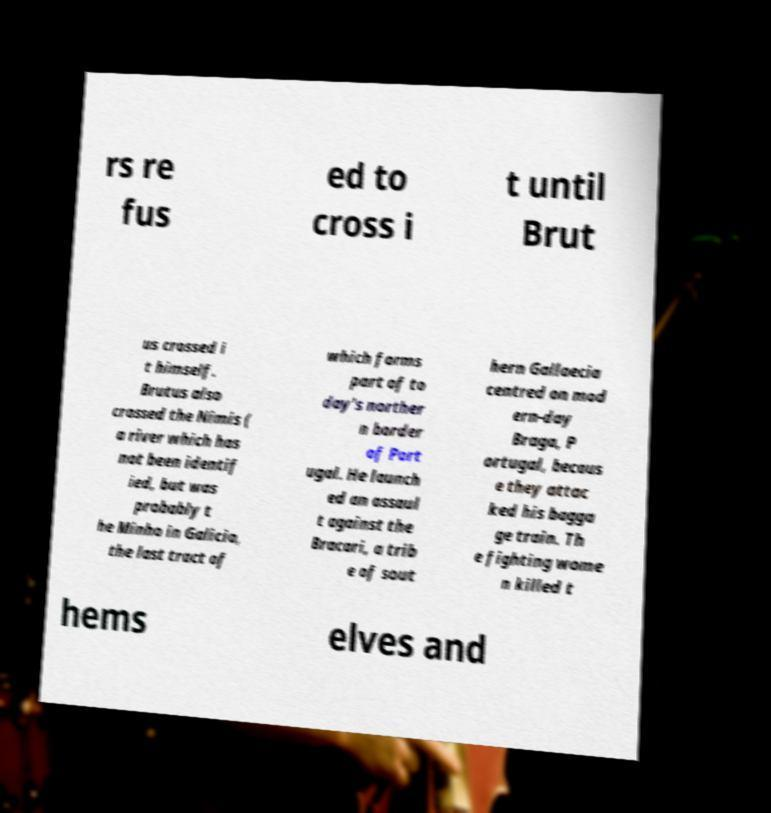For documentation purposes, I need the text within this image transcribed. Could you provide that? rs re fus ed to cross i t until Brut us crossed i t himself. Brutus also crossed the Nimis ( a river which has not been identif ied, but was probably t he Minho in Galicia, the last tract of which forms part of to day's norther n border of Port ugal. He launch ed an assaul t against the Bracari, a trib e of sout hern Gallaecia centred on mod ern-day Braga, P ortugal, becaus e they attac ked his bagga ge train. Th e fighting wome n killed t hems elves and 